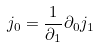Convert formula to latex. <formula><loc_0><loc_0><loc_500><loc_500>j _ { 0 } = \frac { 1 } { \partial _ { 1 } } \partial _ { 0 } j _ { 1 }</formula> 